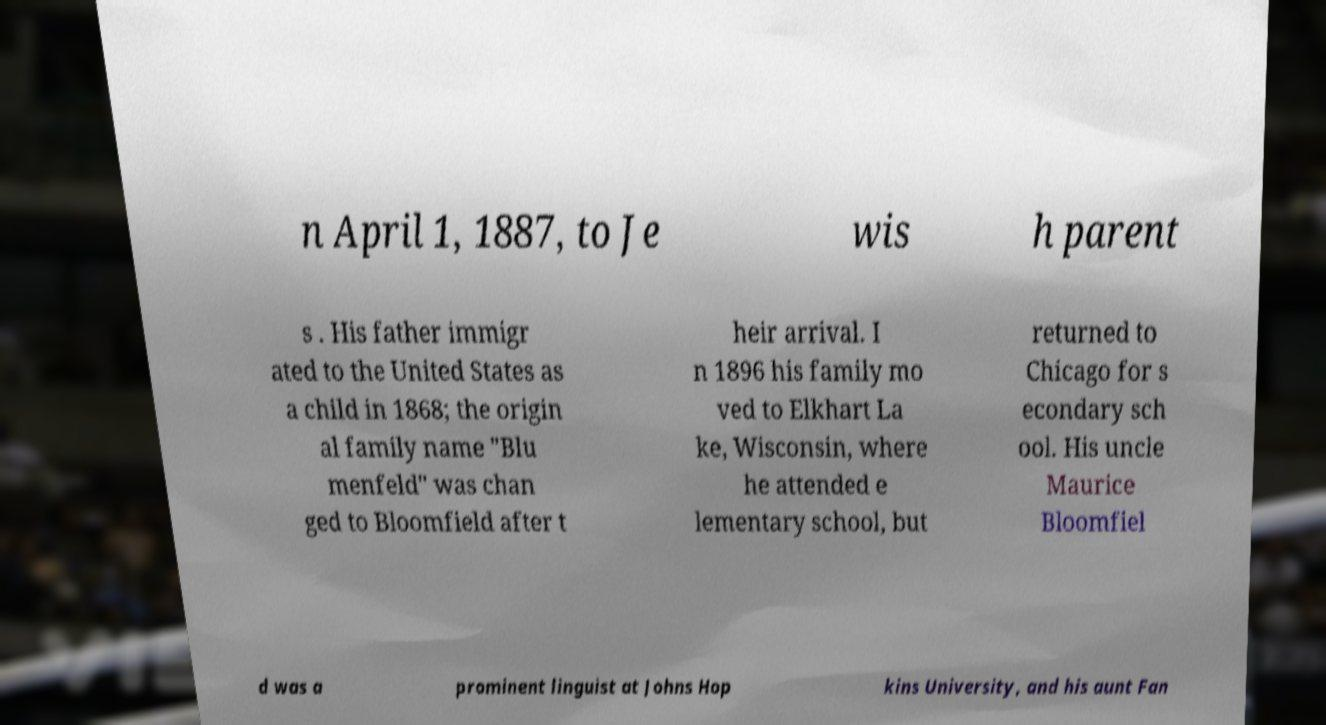What messages or text are displayed in this image? I need them in a readable, typed format. n April 1, 1887, to Je wis h parent s . His father immigr ated to the United States as a child in 1868; the origin al family name "Blu menfeld" was chan ged to Bloomfield after t heir arrival. I n 1896 his family mo ved to Elkhart La ke, Wisconsin, where he attended e lementary school, but returned to Chicago for s econdary sch ool. His uncle Maurice Bloomfiel d was a prominent linguist at Johns Hop kins University, and his aunt Fan 